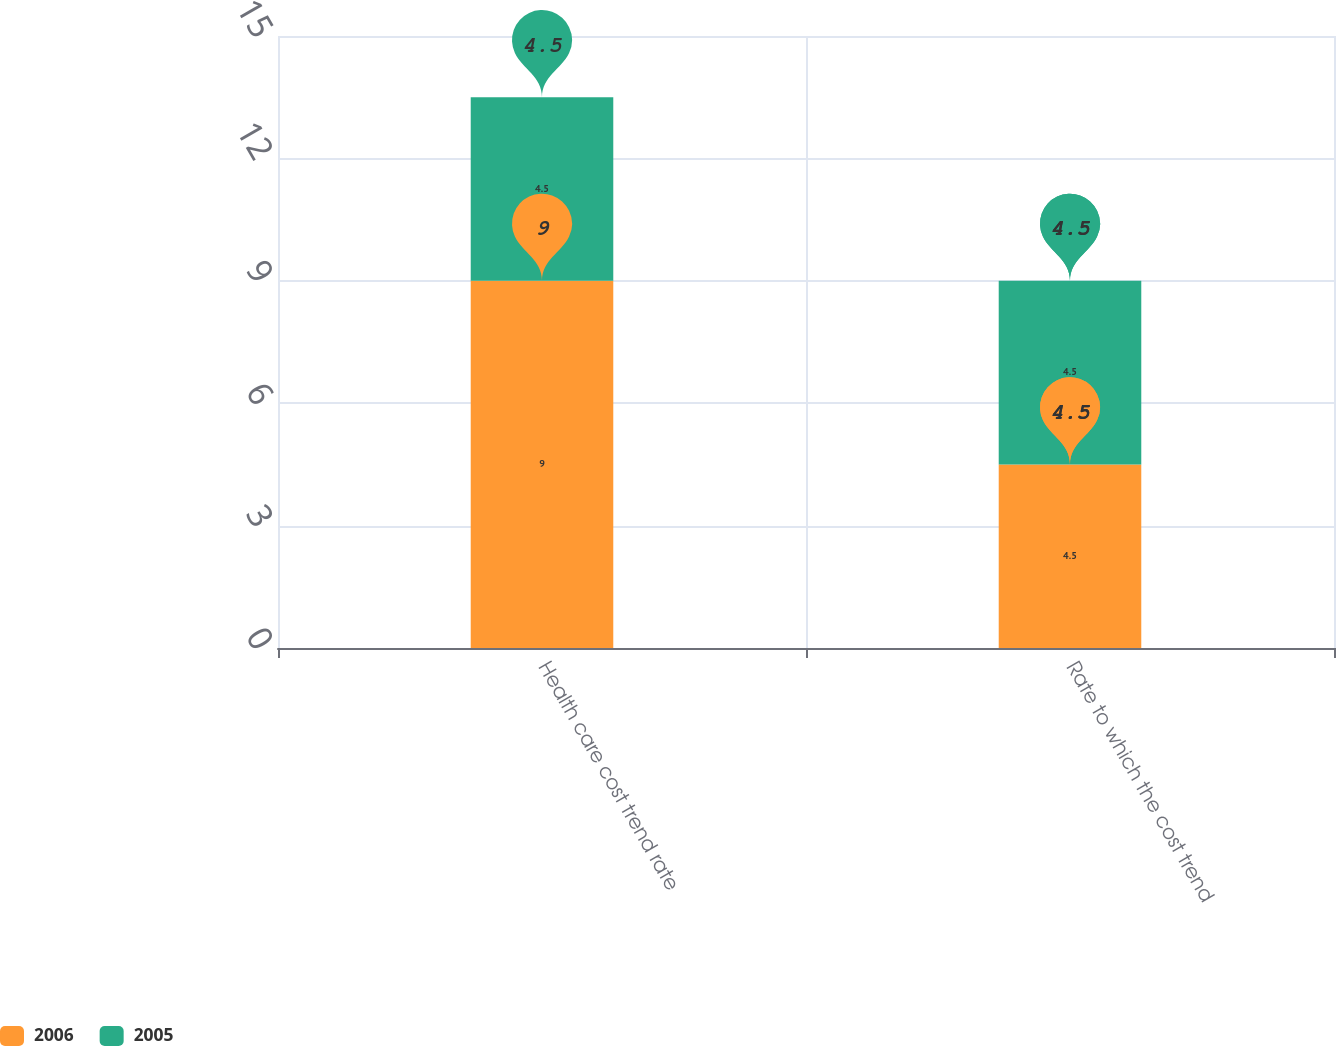Convert chart. <chart><loc_0><loc_0><loc_500><loc_500><stacked_bar_chart><ecel><fcel>Health care cost trend rate<fcel>Rate to which the cost trend<nl><fcel>2006<fcel>9<fcel>4.5<nl><fcel>2005<fcel>4.5<fcel>4.5<nl></chart> 